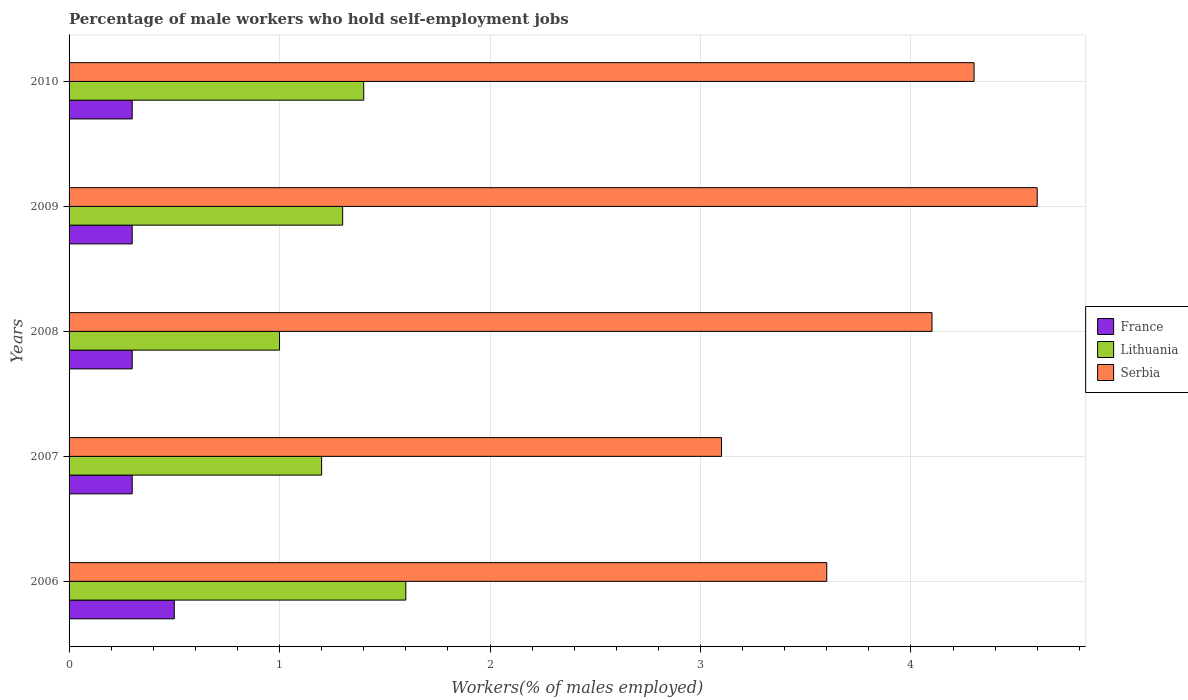How many groups of bars are there?
Ensure brevity in your answer.  5. What is the label of the 5th group of bars from the top?
Offer a terse response. 2006. In how many cases, is the number of bars for a given year not equal to the number of legend labels?
Keep it short and to the point. 0. What is the percentage of self-employed male workers in Serbia in 2008?
Your answer should be very brief. 4.1. In which year was the percentage of self-employed male workers in France minimum?
Offer a terse response. 2007. What is the total percentage of self-employed male workers in Serbia in the graph?
Your response must be concise. 19.7. What is the difference between the percentage of self-employed male workers in Lithuania in 2007 and that in 2008?
Provide a short and direct response. 0.2. What is the difference between the percentage of self-employed male workers in France in 2010 and the percentage of self-employed male workers in Lithuania in 2009?
Keep it short and to the point. -1. In the year 2007, what is the difference between the percentage of self-employed male workers in France and percentage of self-employed male workers in Lithuania?
Offer a terse response. -0.9. In how many years, is the percentage of self-employed male workers in Lithuania greater than 0.8 %?
Your answer should be very brief. 5. What is the ratio of the percentage of self-employed male workers in Lithuania in 2006 to that in 2007?
Make the answer very short. 1.33. Is the percentage of self-employed male workers in Serbia in 2007 less than that in 2010?
Give a very brief answer. Yes. Is the difference between the percentage of self-employed male workers in France in 2007 and 2010 greater than the difference between the percentage of self-employed male workers in Lithuania in 2007 and 2010?
Make the answer very short. Yes. What is the difference between the highest and the second highest percentage of self-employed male workers in Serbia?
Make the answer very short. 0.3. In how many years, is the percentage of self-employed male workers in Lithuania greater than the average percentage of self-employed male workers in Lithuania taken over all years?
Your answer should be very brief. 2. Is the sum of the percentage of self-employed male workers in France in 2006 and 2009 greater than the maximum percentage of self-employed male workers in Serbia across all years?
Offer a very short reply. No. What does the 2nd bar from the top in 2006 represents?
Your answer should be very brief. Lithuania. What does the 3rd bar from the bottom in 2010 represents?
Your answer should be very brief. Serbia. Are all the bars in the graph horizontal?
Provide a short and direct response. Yes. What is the difference between two consecutive major ticks on the X-axis?
Your answer should be compact. 1. Does the graph contain any zero values?
Keep it short and to the point. No. How many legend labels are there?
Your answer should be compact. 3. What is the title of the graph?
Offer a terse response. Percentage of male workers who hold self-employment jobs. Does "Costa Rica" appear as one of the legend labels in the graph?
Offer a very short reply. No. What is the label or title of the X-axis?
Offer a terse response. Workers(% of males employed). What is the label or title of the Y-axis?
Provide a short and direct response. Years. What is the Workers(% of males employed) in France in 2006?
Your response must be concise. 0.5. What is the Workers(% of males employed) of Lithuania in 2006?
Provide a short and direct response. 1.6. What is the Workers(% of males employed) of Serbia in 2006?
Your response must be concise. 3.6. What is the Workers(% of males employed) in France in 2007?
Offer a terse response. 0.3. What is the Workers(% of males employed) of Lithuania in 2007?
Keep it short and to the point. 1.2. What is the Workers(% of males employed) of Serbia in 2007?
Your answer should be compact. 3.1. What is the Workers(% of males employed) in France in 2008?
Provide a succinct answer. 0.3. What is the Workers(% of males employed) of Serbia in 2008?
Your answer should be very brief. 4.1. What is the Workers(% of males employed) in France in 2009?
Offer a terse response. 0.3. What is the Workers(% of males employed) in Lithuania in 2009?
Give a very brief answer. 1.3. What is the Workers(% of males employed) in Serbia in 2009?
Offer a terse response. 4.6. What is the Workers(% of males employed) of France in 2010?
Ensure brevity in your answer.  0.3. What is the Workers(% of males employed) of Lithuania in 2010?
Make the answer very short. 1.4. What is the Workers(% of males employed) of Serbia in 2010?
Offer a very short reply. 4.3. Across all years, what is the maximum Workers(% of males employed) in Lithuania?
Your response must be concise. 1.6. Across all years, what is the maximum Workers(% of males employed) of Serbia?
Your answer should be compact. 4.6. Across all years, what is the minimum Workers(% of males employed) in France?
Keep it short and to the point. 0.3. Across all years, what is the minimum Workers(% of males employed) of Lithuania?
Your answer should be compact. 1. Across all years, what is the minimum Workers(% of males employed) in Serbia?
Provide a succinct answer. 3.1. What is the difference between the Workers(% of males employed) of France in 2006 and that in 2007?
Your answer should be very brief. 0.2. What is the difference between the Workers(% of males employed) of Lithuania in 2006 and that in 2007?
Ensure brevity in your answer.  0.4. What is the difference between the Workers(% of males employed) in Serbia in 2006 and that in 2007?
Your response must be concise. 0.5. What is the difference between the Workers(% of males employed) of Serbia in 2006 and that in 2008?
Your answer should be very brief. -0.5. What is the difference between the Workers(% of males employed) in Lithuania in 2006 and that in 2009?
Offer a terse response. 0.3. What is the difference between the Workers(% of males employed) of Serbia in 2006 and that in 2009?
Offer a very short reply. -1. What is the difference between the Workers(% of males employed) of Lithuania in 2006 and that in 2010?
Your answer should be compact. 0.2. What is the difference between the Workers(% of males employed) of Serbia in 2006 and that in 2010?
Offer a very short reply. -0.7. What is the difference between the Workers(% of males employed) in France in 2007 and that in 2008?
Provide a short and direct response. 0. What is the difference between the Workers(% of males employed) of France in 2007 and that in 2009?
Offer a very short reply. 0. What is the difference between the Workers(% of males employed) of Lithuania in 2007 and that in 2009?
Offer a terse response. -0.1. What is the difference between the Workers(% of males employed) in Serbia in 2007 and that in 2009?
Ensure brevity in your answer.  -1.5. What is the difference between the Workers(% of males employed) of France in 2007 and that in 2010?
Your response must be concise. 0. What is the difference between the Workers(% of males employed) of Serbia in 2007 and that in 2010?
Your answer should be very brief. -1.2. What is the difference between the Workers(% of males employed) of France in 2008 and that in 2009?
Give a very brief answer. 0. What is the difference between the Workers(% of males employed) of Lithuania in 2008 and that in 2009?
Your answer should be compact. -0.3. What is the difference between the Workers(% of males employed) in Serbia in 2008 and that in 2010?
Ensure brevity in your answer.  -0.2. What is the difference between the Workers(% of males employed) in Lithuania in 2009 and that in 2010?
Ensure brevity in your answer.  -0.1. What is the difference between the Workers(% of males employed) in Serbia in 2009 and that in 2010?
Your answer should be very brief. 0.3. What is the difference between the Workers(% of males employed) of France in 2006 and the Workers(% of males employed) of Serbia in 2007?
Your answer should be compact. -2.6. What is the difference between the Workers(% of males employed) of Lithuania in 2006 and the Workers(% of males employed) of Serbia in 2007?
Provide a short and direct response. -1.5. What is the difference between the Workers(% of males employed) in France in 2006 and the Workers(% of males employed) in Lithuania in 2008?
Ensure brevity in your answer.  -0.5. What is the difference between the Workers(% of males employed) in France in 2006 and the Workers(% of males employed) in Lithuania in 2009?
Provide a short and direct response. -0.8. What is the difference between the Workers(% of males employed) of France in 2006 and the Workers(% of males employed) of Serbia in 2010?
Your response must be concise. -3.8. What is the difference between the Workers(% of males employed) of France in 2007 and the Workers(% of males employed) of Serbia in 2008?
Your answer should be compact. -3.8. What is the difference between the Workers(% of males employed) in France in 2008 and the Workers(% of males employed) in Serbia in 2010?
Offer a very short reply. -4. What is the difference between the Workers(% of males employed) in France in 2009 and the Workers(% of males employed) in Lithuania in 2010?
Make the answer very short. -1.1. What is the difference between the Workers(% of males employed) in Lithuania in 2009 and the Workers(% of males employed) in Serbia in 2010?
Give a very brief answer. -3. What is the average Workers(% of males employed) of France per year?
Provide a short and direct response. 0.34. What is the average Workers(% of males employed) in Serbia per year?
Keep it short and to the point. 3.94. In the year 2006, what is the difference between the Workers(% of males employed) of France and Workers(% of males employed) of Lithuania?
Your answer should be very brief. -1.1. In the year 2006, what is the difference between the Workers(% of males employed) of France and Workers(% of males employed) of Serbia?
Your answer should be very brief. -3.1. In the year 2007, what is the difference between the Workers(% of males employed) of France and Workers(% of males employed) of Lithuania?
Your response must be concise. -0.9. In the year 2007, what is the difference between the Workers(% of males employed) in France and Workers(% of males employed) in Serbia?
Provide a succinct answer. -2.8. In the year 2008, what is the difference between the Workers(% of males employed) in France and Workers(% of males employed) in Serbia?
Keep it short and to the point. -3.8. In the year 2008, what is the difference between the Workers(% of males employed) of Lithuania and Workers(% of males employed) of Serbia?
Your answer should be compact. -3.1. In the year 2009, what is the difference between the Workers(% of males employed) in France and Workers(% of males employed) in Lithuania?
Provide a short and direct response. -1. In the year 2009, what is the difference between the Workers(% of males employed) of France and Workers(% of males employed) of Serbia?
Your answer should be compact. -4.3. In the year 2009, what is the difference between the Workers(% of males employed) in Lithuania and Workers(% of males employed) in Serbia?
Your response must be concise. -3.3. What is the ratio of the Workers(% of males employed) in Lithuania in 2006 to that in 2007?
Keep it short and to the point. 1.33. What is the ratio of the Workers(% of males employed) of Serbia in 2006 to that in 2007?
Your answer should be compact. 1.16. What is the ratio of the Workers(% of males employed) of France in 2006 to that in 2008?
Make the answer very short. 1.67. What is the ratio of the Workers(% of males employed) in Serbia in 2006 to that in 2008?
Provide a succinct answer. 0.88. What is the ratio of the Workers(% of males employed) of Lithuania in 2006 to that in 2009?
Ensure brevity in your answer.  1.23. What is the ratio of the Workers(% of males employed) in Serbia in 2006 to that in 2009?
Provide a succinct answer. 0.78. What is the ratio of the Workers(% of males employed) in France in 2006 to that in 2010?
Give a very brief answer. 1.67. What is the ratio of the Workers(% of males employed) in Lithuania in 2006 to that in 2010?
Your response must be concise. 1.14. What is the ratio of the Workers(% of males employed) in Serbia in 2006 to that in 2010?
Keep it short and to the point. 0.84. What is the ratio of the Workers(% of males employed) of France in 2007 to that in 2008?
Your answer should be very brief. 1. What is the ratio of the Workers(% of males employed) of Serbia in 2007 to that in 2008?
Give a very brief answer. 0.76. What is the ratio of the Workers(% of males employed) of France in 2007 to that in 2009?
Ensure brevity in your answer.  1. What is the ratio of the Workers(% of males employed) of Lithuania in 2007 to that in 2009?
Offer a terse response. 0.92. What is the ratio of the Workers(% of males employed) in Serbia in 2007 to that in 2009?
Keep it short and to the point. 0.67. What is the ratio of the Workers(% of males employed) in France in 2007 to that in 2010?
Your answer should be compact. 1. What is the ratio of the Workers(% of males employed) in Serbia in 2007 to that in 2010?
Keep it short and to the point. 0.72. What is the ratio of the Workers(% of males employed) in Lithuania in 2008 to that in 2009?
Provide a short and direct response. 0.77. What is the ratio of the Workers(% of males employed) in Serbia in 2008 to that in 2009?
Provide a succinct answer. 0.89. What is the ratio of the Workers(% of males employed) in Serbia in 2008 to that in 2010?
Provide a short and direct response. 0.95. What is the ratio of the Workers(% of males employed) in Serbia in 2009 to that in 2010?
Provide a short and direct response. 1.07. What is the difference between the highest and the second highest Workers(% of males employed) in Lithuania?
Your answer should be very brief. 0.2. What is the difference between the highest and the second highest Workers(% of males employed) of Serbia?
Give a very brief answer. 0.3. 